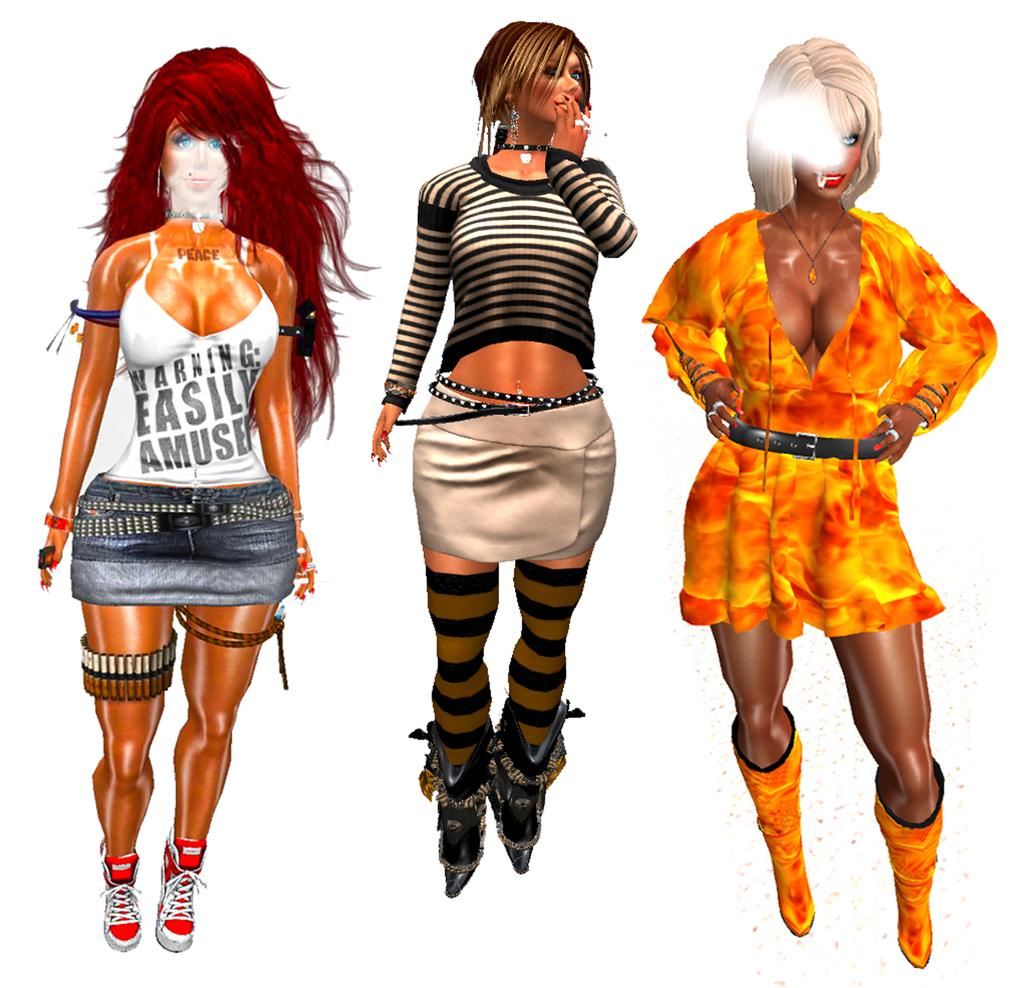<image>
Describe the image concisely. Three computer animations of women are lined up, with the first one wearing a shirt that says Warning - Easily Amused. 